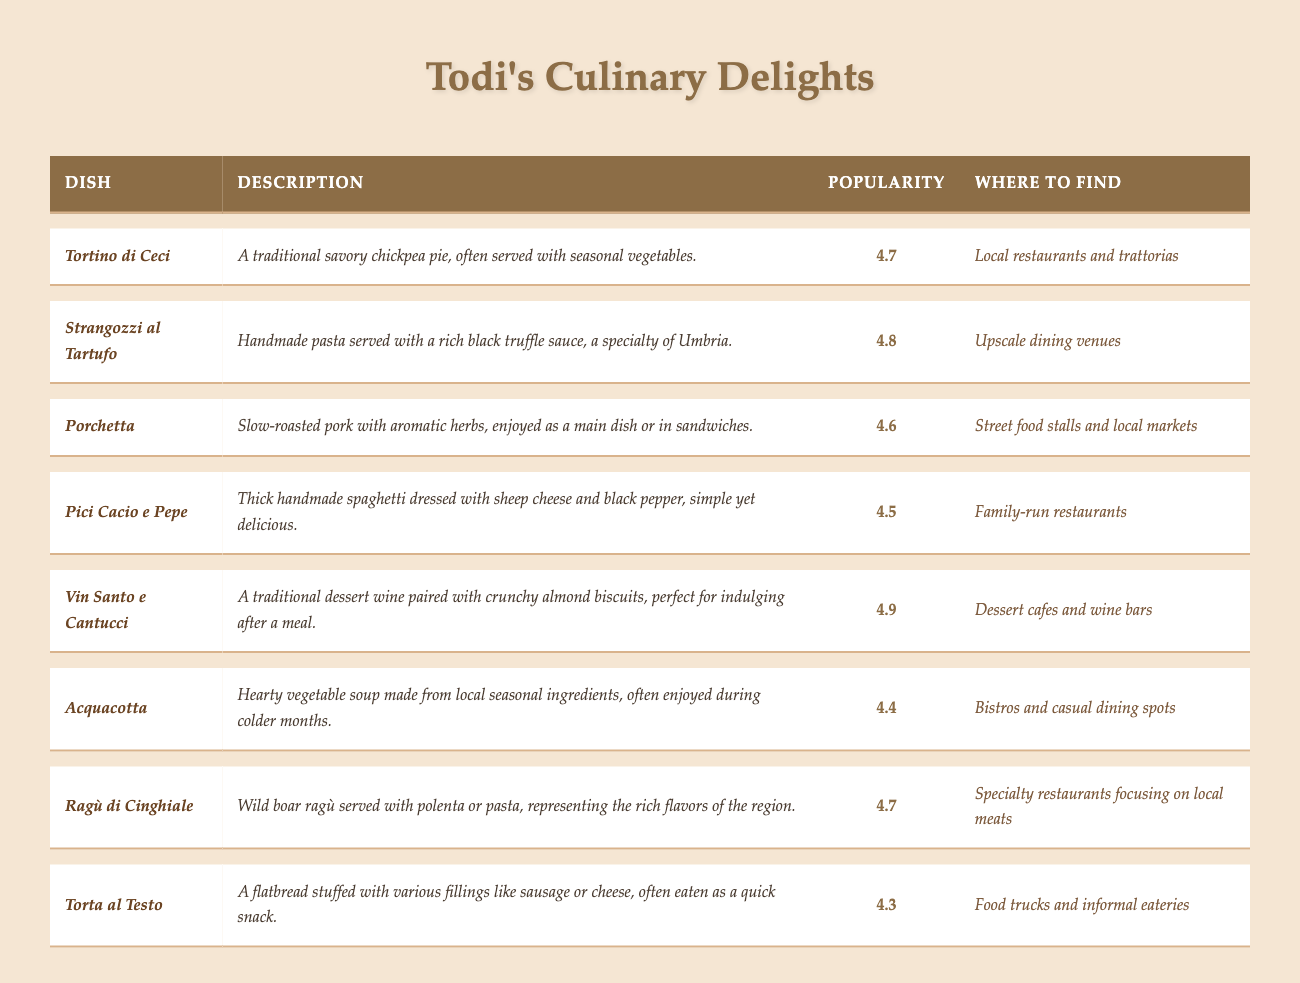What is the highest-rated dish in Todi? The dish with the highest popularity rating in the table is _Vin Santo e Cantucci_, which has a rating of 4.9.
Answer: _Vin Santo e Cantucci_ Which dish has a popularity rating of 4.5? The dish with a popularity rating of 4.5 is _Pici Cacio e Pepe_.
Answer: _Pici Cacio e Pepe_ Does _Porchetta_ have a higher or lower rating than _Torta al Testo_? _Porchetta_ has a rating of 4.6, while _Torta al Testo_ has a rating of 4.3. Therefore, _Porchetta_ has a higher rating than _Torta al Testo_.
Answer: Higher List the dishes served in local markets. The dish served in local markets is _Porchetta_.
Answer: _Porchetta_ Which dishes are rated above 4.6? The dishes rated above 4.6 are _Strangozzi al Tartufo_ (4.8), _Vin Santo e Cantucci_ (4.9), and _Ragù di Cinghiale_ (4.7).
Answer: _Strangozzi al Tartufo, Vin Santo e Cantucci, Ragù di Cinghiale_ How many dishes are served in family-run restaurants? There is one dish, which is _Pici Cacio e Pepe_, served in family-run restaurants.
Answer: 1 What dish has the lowest popularity rating? The dish with the lowest popularity rating is _Acquacotta_, with a rating of 4.4.
Answer: _Acquacotta_ What is the average popularity rating of all the dishes listed? To find the average, sum all the popularity ratings: (4.7 + 4.8 + 4.6 + 4.5 + 4.9 + 4.4 + 4.7 + 4.3 = 36.9). There are 8 dishes, so the average rating is 36.9 / 8 = 4.6125, which can be rounded to 4.6.
Answer: 4.6 Where can you find _Strangozzi al Tartufo_? _Strangozzi al Tartufo_ is served in upscale dining venues.
Answer: Upscale dining venues Which dish is both popular (above 4.5) and commonly found in street food stalls? _Porchetta_ is the dish that is popular with a rating above 4.5 (4.6) and is commonly found in street food stalls.
Answer: _Porchetta_ 